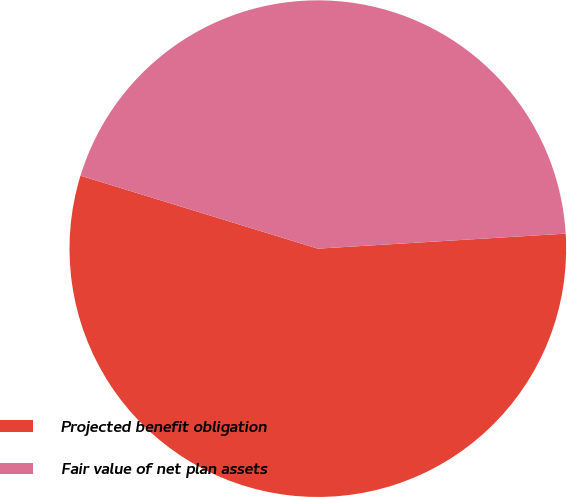Convert chart to OTSL. <chart><loc_0><loc_0><loc_500><loc_500><pie_chart><fcel>Projected benefit obligation<fcel>Fair value of net plan assets<nl><fcel>55.71%<fcel>44.29%<nl></chart> 